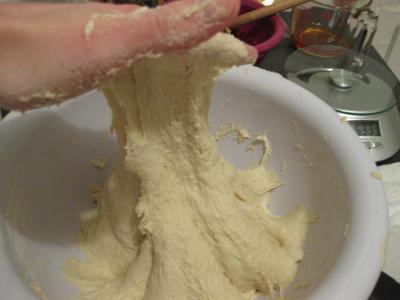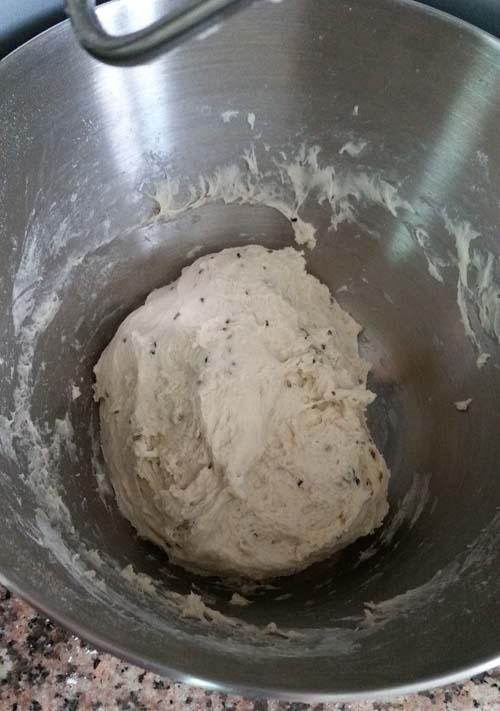The first image is the image on the left, the second image is the image on the right. For the images shown, is this caption "A person is lifting dough." true? Answer yes or no. Yes. The first image is the image on the left, the second image is the image on the right. For the images displayed, is the sentence "In at least one image a person's hand has wet dough stretching down." factually correct? Answer yes or no. Yes. 